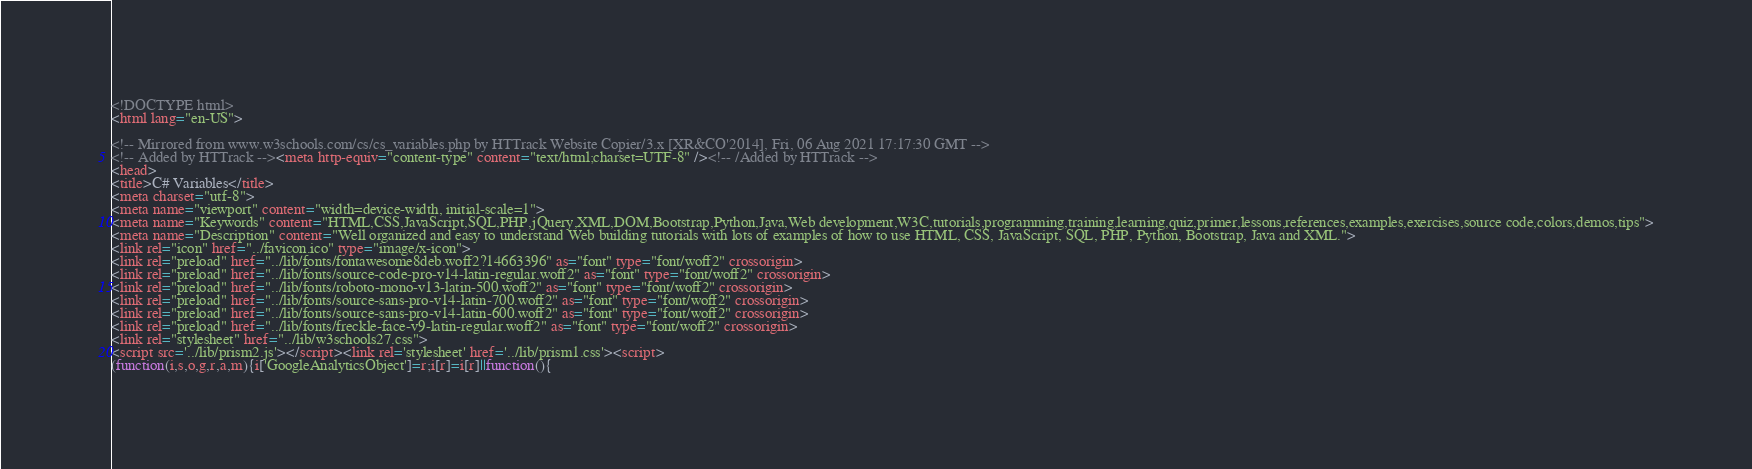Convert code to text. <code><loc_0><loc_0><loc_500><loc_500><_HTML_><!DOCTYPE html>
<html lang="en-US">

<!-- Mirrored from www.w3schools.com/cs/cs_variables.php by HTTrack Website Copier/3.x [XR&CO'2014], Fri, 06 Aug 2021 17:17:30 GMT -->
<!-- Added by HTTrack --><meta http-equiv="content-type" content="text/html;charset=UTF-8" /><!-- /Added by HTTrack -->
<head>
<title>C# Variables</title>
<meta charset="utf-8">
<meta name="viewport" content="width=device-width, initial-scale=1">
<meta name="Keywords" content="HTML,CSS,JavaScript,SQL,PHP,jQuery,XML,DOM,Bootstrap,Python,Java,Web development,W3C,tutorials,programming,training,learning,quiz,primer,lessons,references,examples,exercises,source code,colors,demos,tips">
<meta name="Description" content="Well organized and easy to understand Web building tutorials with lots of examples of how to use HTML, CSS, JavaScript, SQL, PHP, Python, Bootstrap, Java and XML.">
<link rel="icon" href="../favicon.ico" type="image/x-icon">
<link rel="preload" href="../lib/fonts/fontawesome8deb.woff2?14663396" as="font" type="font/woff2" crossorigin> 
<link rel="preload" href="../lib/fonts/source-code-pro-v14-latin-regular.woff2" as="font" type="font/woff2" crossorigin> 
<link rel="preload" href="../lib/fonts/roboto-mono-v13-latin-500.woff2" as="font" type="font/woff2" crossorigin> 
<link rel="preload" href="../lib/fonts/source-sans-pro-v14-latin-700.woff2" as="font" type="font/woff2" crossorigin> 
<link rel="preload" href="../lib/fonts/source-sans-pro-v14-latin-600.woff2" as="font" type="font/woff2" crossorigin> 
<link rel="preload" href="../lib/fonts/freckle-face-v9-latin-regular.woff2" as="font" type="font/woff2" crossorigin> 
<link rel="stylesheet" href="../lib/w3schools27.css">
<script src='../lib/prism2.js'></script><link rel='stylesheet' href='../lib/prism1.css'><script>
(function(i,s,o,g,r,a,m){i['GoogleAnalyticsObject']=r;i[r]=i[r]||function(){</code> 